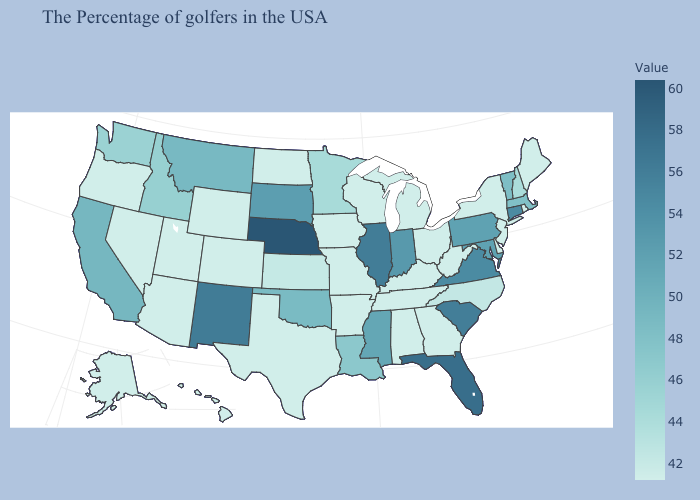Among the states that border Iowa , does Nebraska have the highest value?
Short answer required. Yes. Does Texas have the highest value in the USA?
Give a very brief answer. No. Does Kansas have the lowest value in the MidWest?
Quick response, please. No. Which states have the lowest value in the Northeast?
Concise answer only. Maine, Rhode Island, New York, New Jersey. Among the states that border Illinois , does Kentucky have the highest value?
Answer briefly. No. Does Kentucky have the lowest value in the South?
Quick response, please. Yes. 